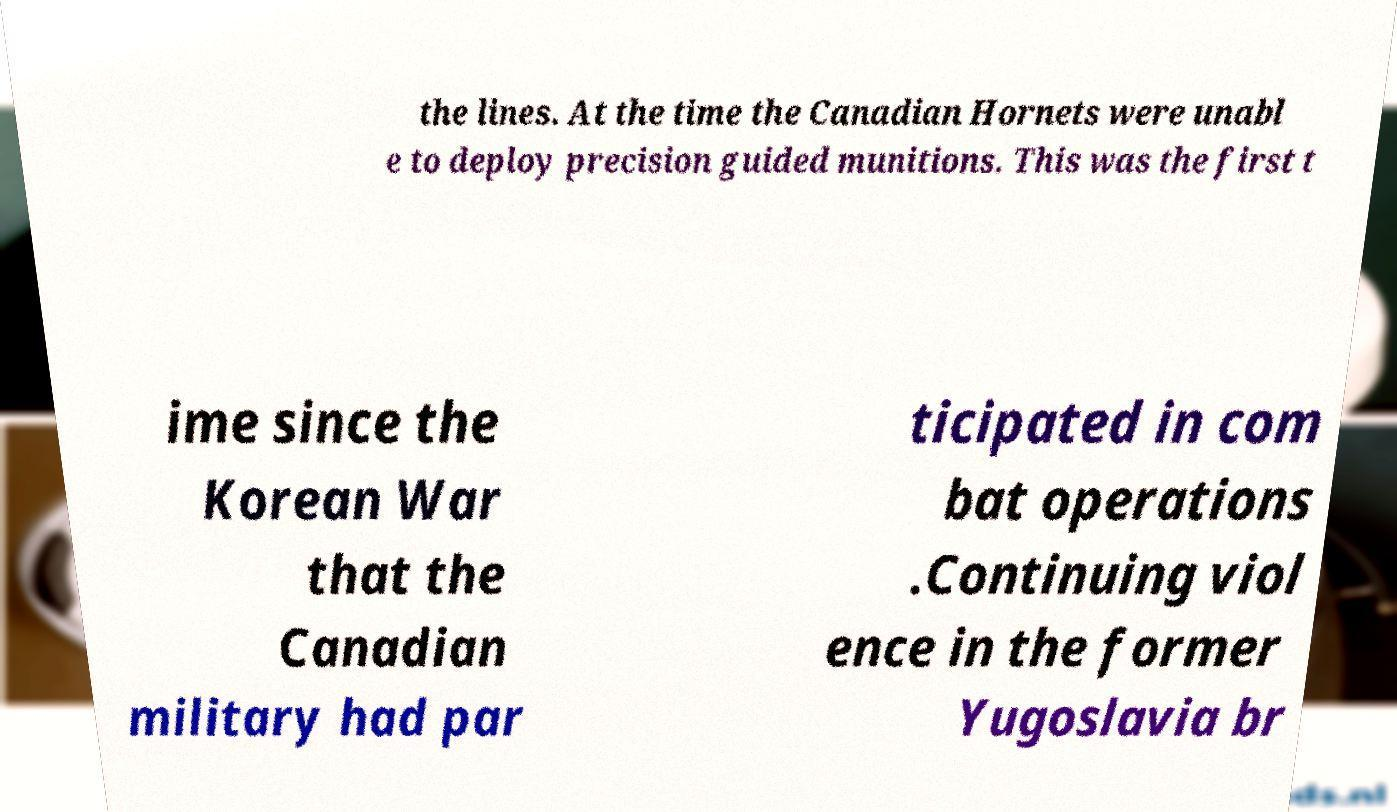There's text embedded in this image that I need extracted. Can you transcribe it verbatim? the lines. At the time the Canadian Hornets were unabl e to deploy precision guided munitions. This was the first t ime since the Korean War that the Canadian military had par ticipated in com bat operations .Continuing viol ence in the former Yugoslavia br 